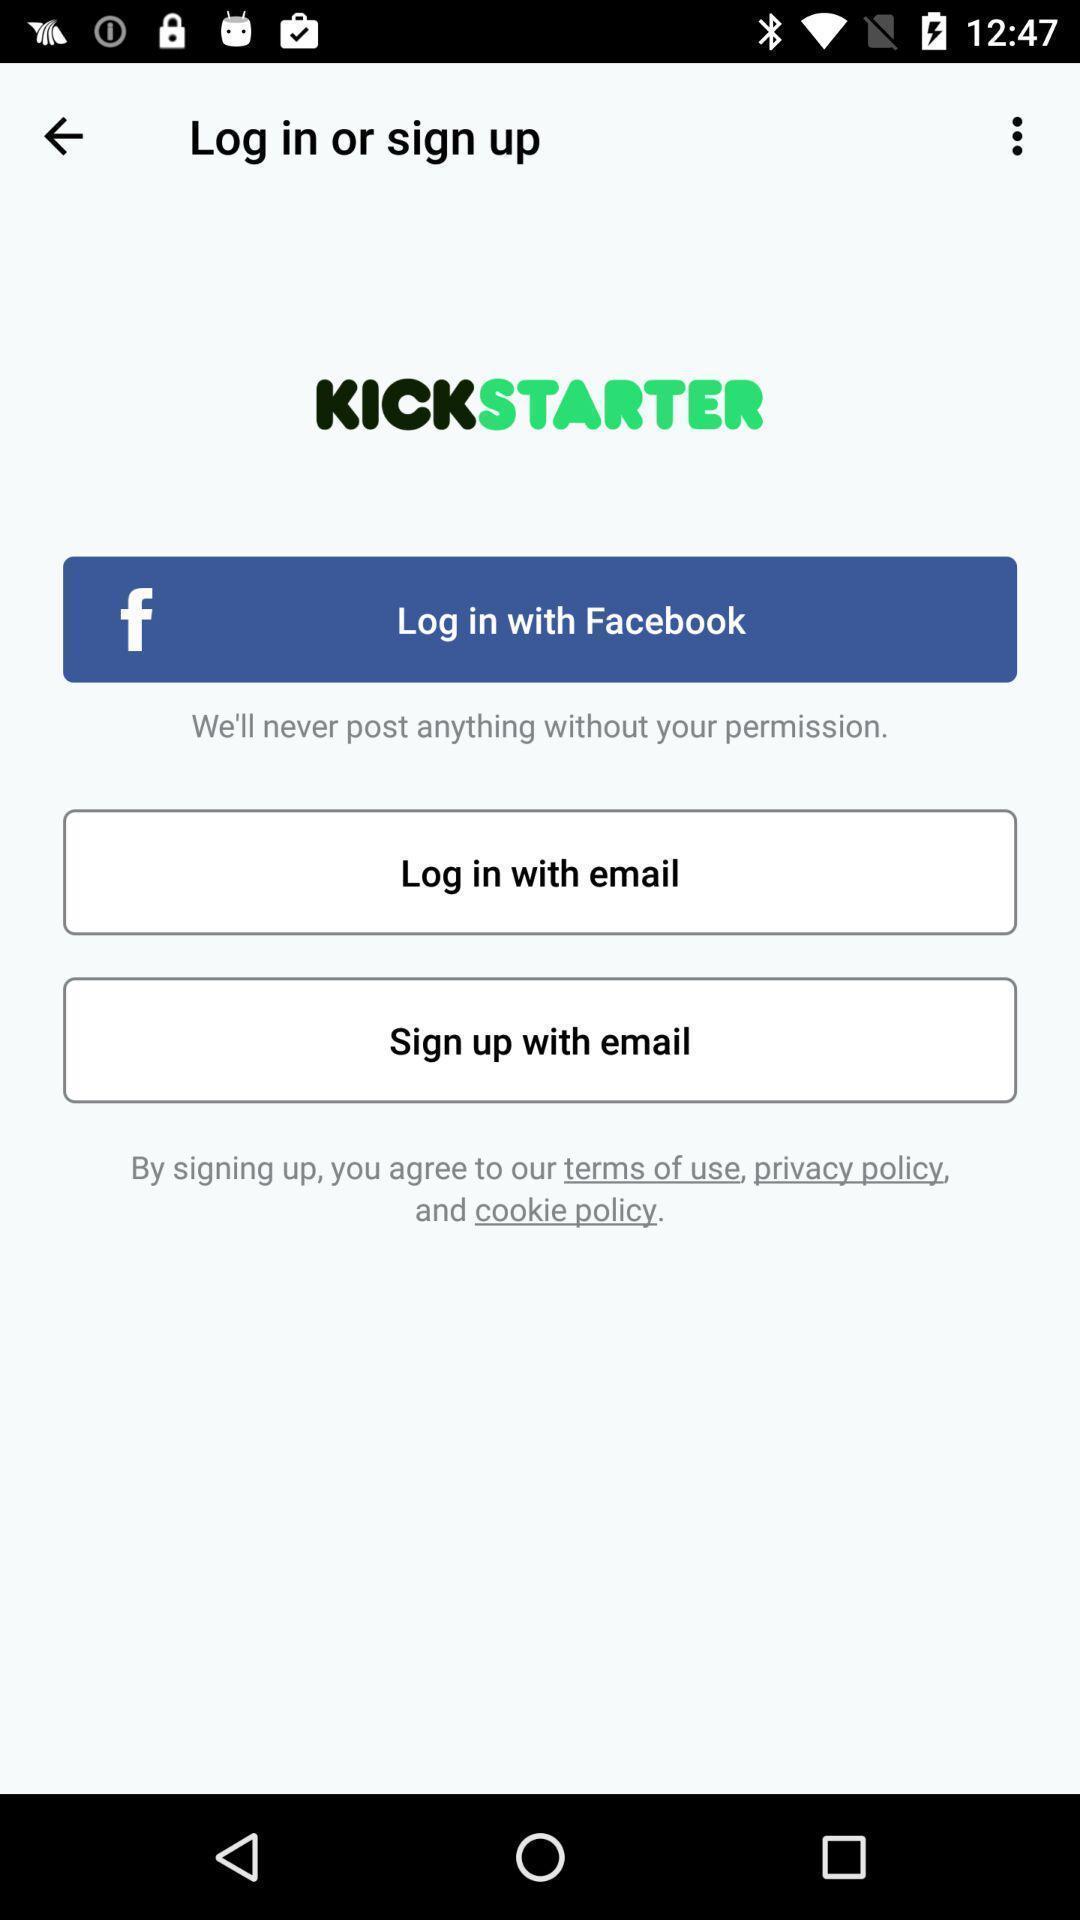Provide a description of this screenshot. Login page with login methods for an app. 